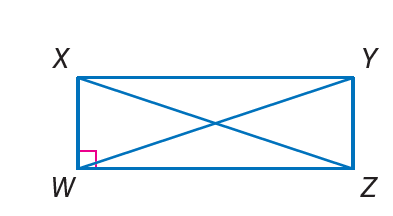Question: Quadrilateral W X Y Z is a rectangle. If X Z = 2 c and Z Y = 6, and X Y = 8, find W Y.
Choices:
A. 6
B. 8
C. 10
D. 20
Answer with the letter. Answer: C Question: Quadrilateral W X Y Z is a rectangle. If X W = 3, W Z = 4, and X Z = b, find Y W.
Choices:
A. 3
B. 4
C. 5
D. 6
Answer with the letter. Answer: C 